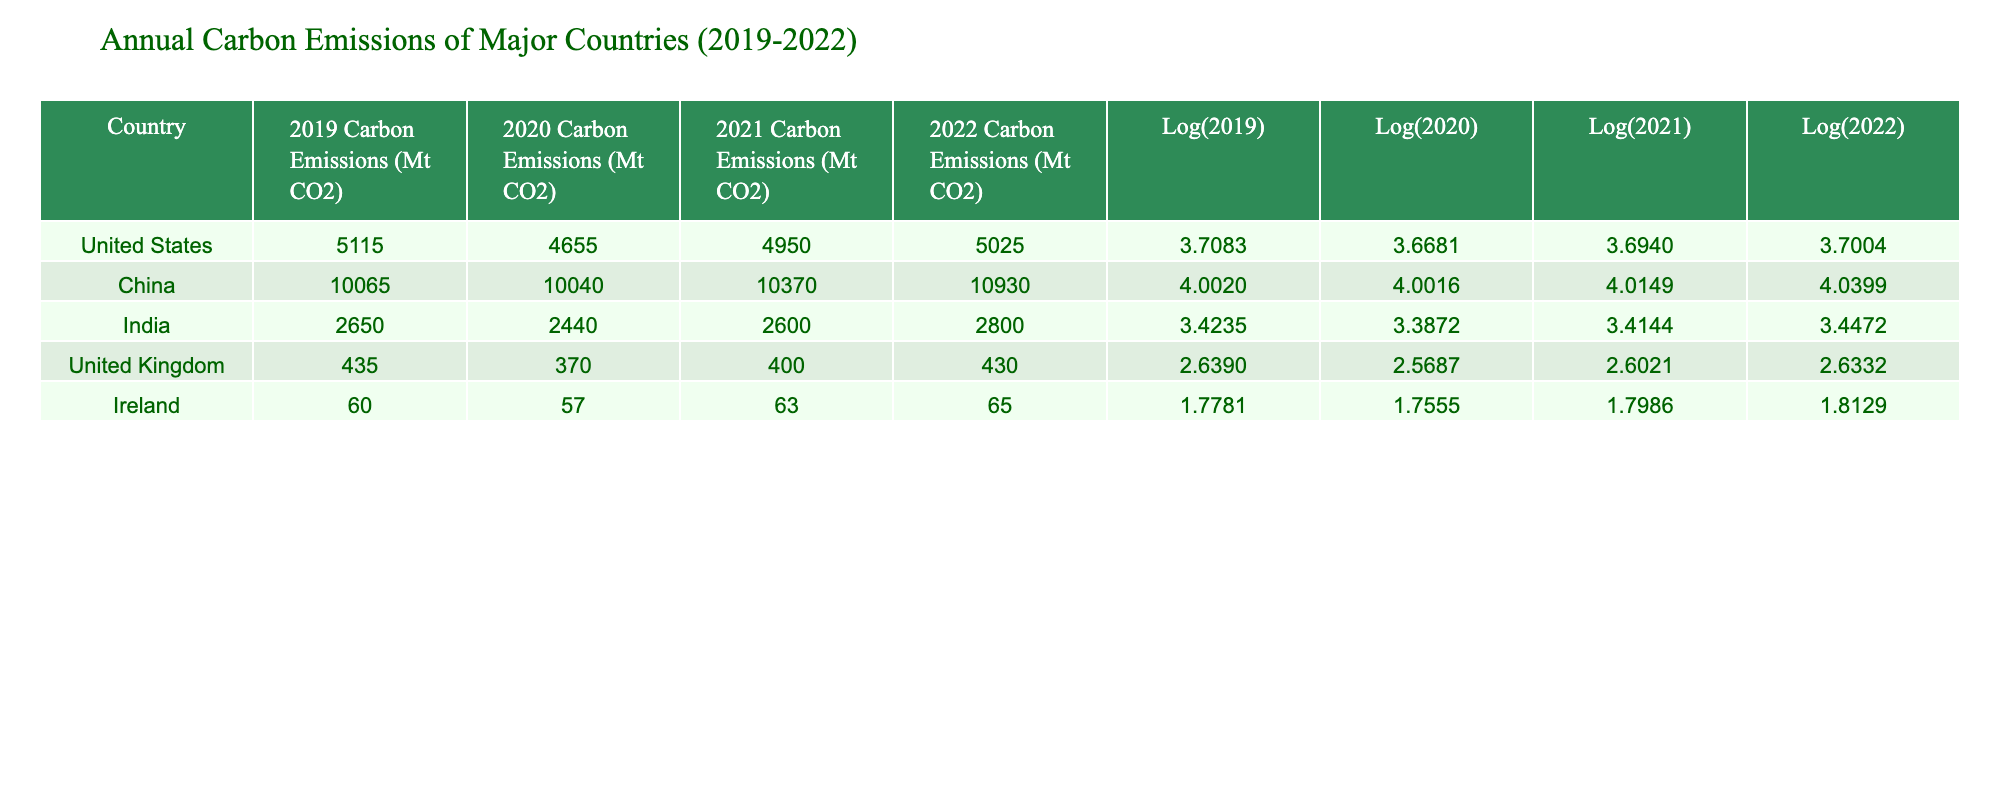What were the carbon emissions of China in 2020? Referring to the "2020 Carbon Emissions (Mt CO2)" column for China, the value is 10040 Mt CO2.
Answer: 10040 Mt CO2 Which country had the lowest carbon emissions in 2022? By comparing the "2022 Carbon Emissions (Mt CO2)" values, Ireland had the lowest emissions at 65 Mt CO2.
Answer: Ireland What is the difference in carbon emissions between the United States in 2019 and 2021? The emissions for the United States were 5115 Mt CO2 in 2019 and 4950 Mt CO2 in 2021. The difference is 5115 - 4950 = 165 Mt CO2.
Answer: 165 Mt CO2 Did India’s carbon emissions increase from 2020 to 2022? India's emissions were 2440 Mt CO2 in 2020 and 2800 Mt CO2 in 2022. Since 2800 is greater than 2440, the emissions indeed increased.
Answer: Yes What is the average carbon emissions of the United Kingdom from 2019 to 2022? To find the average, sum the emissions: (435 + 370 + 400 + 430) = 1635 Mt CO2. Divide by 4 (the number of years): 1635 / 4 = 408.75 Mt CO2.
Answer: 408.75 Mt CO2 What is the logarithmic value of Ireland’s carbon emissions in 2021? The table shows that the logarithmic value for Ireland in 2021 is 1.7986.
Answer: 1.7986 Which country had the highest increase in carbon emissions from 2020 to 2021? To determine the increase, calculate from the values: China increased from 10040 to 10370 (330 Mt CO2), while the United States increased from 4655 to 4950 (295 Mt CO2). The highest increase was for China.
Answer: China What was the ratio of Ireland’s carbon emissions in 2022 to those in 2019? First, identify the emissions: Ireland emitted 65 Mt CO2 in 2022 and 60 Mt CO2 in 2019. The ratio is 65/60 = 1.0833.
Answer: 1.0833 